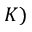<formula> <loc_0><loc_0><loc_500><loc_500>K )</formula> 